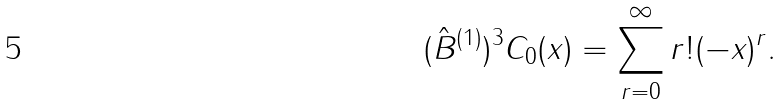Convert formula to latex. <formula><loc_0><loc_0><loc_500><loc_500>( \hat { B } ^ { ( 1 ) } ) ^ { 3 } C _ { 0 } ( x ) = \sum _ { r = 0 } ^ { \infty } r ! ( - x ) ^ { r } .</formula> 